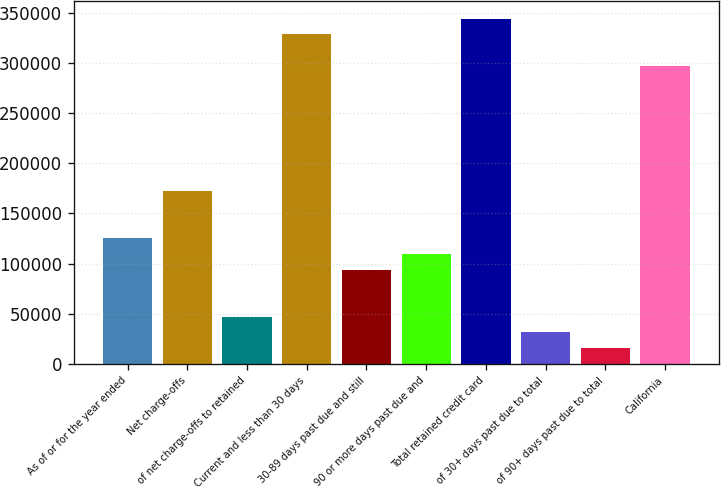Convert chart. <chart><loc_0><loc_0><loc_500><loc_500><bar_chart><fcel>As of or for the year ended<fcel>Net charge-offs<fcel>of net charge-offs to retained<fcel>Current and less than 30 days<fcel>30-89 days past due and still<fcel>90 or more days past due and<fcel>Total retained credit card<fcel>of 30+ days past due to total<fcel>of 90+ days past due to total<fcel>California<nl><fcel>125293<fcel>172278<fcel>46985.4<fcel>328893<fcel>93969.9<fcel>109631<fcel>344554<fcel>31323.8<fcel>15662.3<fcel>297570<nl></chart> 